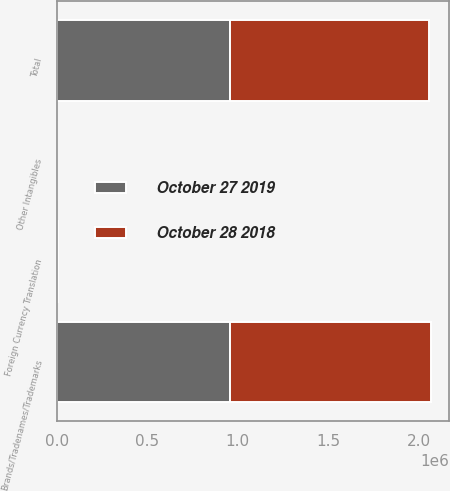<chart> <loc_0><loc_0><loc_500><loc_500><stacked_bar_chart><ecel><fcel>Brands/Tradenames/Trademarks<fcel>Other Intangibles<fcel>Foreign Currency Translation<fcel>Total<nl><fcel>October 27 2019<fcel>959400<fcel>184<fcel>3803<fcel>955781<nl><fcel>October 28 2018<fcel>1.10812e+06<fcel>184<fcel>3484<fcel>1.10482e+06<nl></chart> 